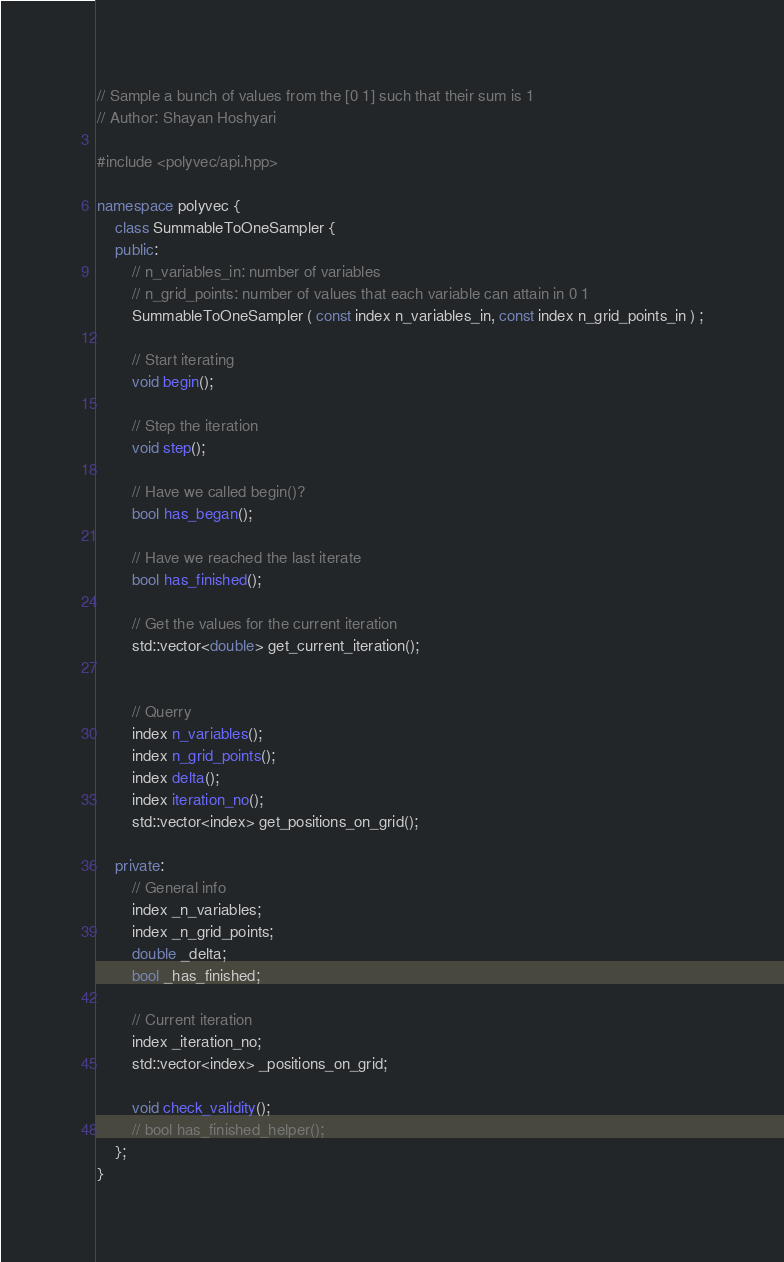<code> <loc_0><loc_0><loc_500><loc_500><_C++_>// Sample a bunch of values from the [0 1] such that their sum is 1
// Author: Shayan Hoshyari

#include <polyvec/api.hpp>

namespace polyvec {
    class SummableToOneSampler {
    public:
        // n_variables_in: number of variables
        // n_grid_points: number of values that each variable can attain in 0 1
        SummableToOneSampler ( const index n_variables_in, const index n_grid_points_in ) ;

        // Start iterating
        void begin();

        // Step the iteration
        void step();

        // Have we called begin()?
        bool has_began();

        // Have we reached the last iterate
        bool has_finished();

        // Get the values for the current iteration
        std::vector<double> get_current_iteration();


        // Querry
        index n_variables();
        index n_grid_points();
        index delta();
        index iteration_no();
        std::vector<index> get_positions_on_grid();

    private:
        // General info
        index _n_variables;
        index _n_grid_points;
        double _delta;
        bool _has_finished;

        // Current iteration
        index _iteration_no;
        std::vector<index> _positions_on_grid;

        void check_validity();
        // bool has_finished_helper();
    };
}</code> 